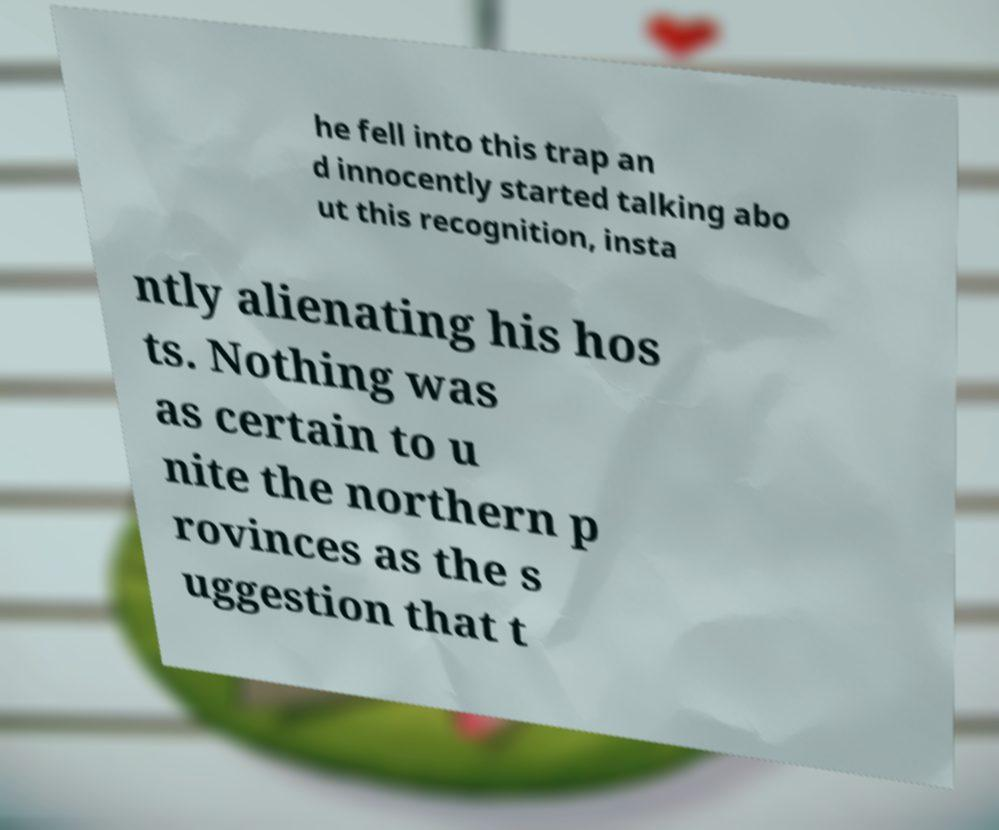Could you extract and type out the text from this image? he fell into this trap an d innocently started talking abo ut this recognition, insta ntly alienating his hos ts. Nothing was as certain to u nite the northern p rovinces as the s uggestion that t 